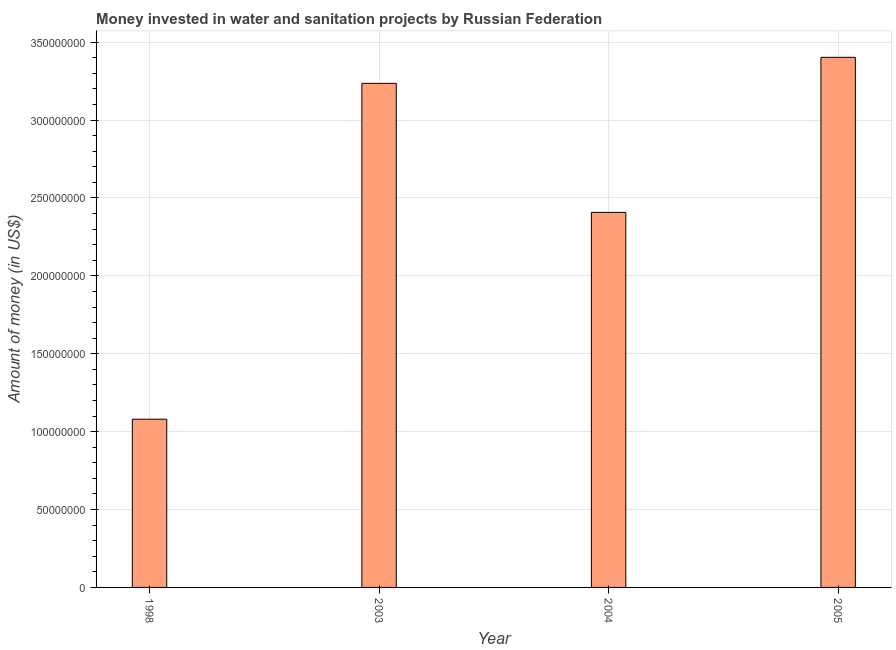What is the title of the graph?
Offer a very short reply. Money invested in water and sanitation projects by Russian Federation. What is the label or title of the X-axis?
Provide a succinct answer. Year. What is the label or title of the Y-axis?
Your response must be concise. Amount of money (in US$). What is the investment in 2003?
Offer a very short reply. 3.24e+08. Across all years, what is the maximum investment?
Give a very brief answer. 3.40e+08. Across all years, what is the minimum investment?
Your answer should be compact. 1.08e+08. What is the sum of the investment?
Ensure brevity in your answer.  1.01e+09. What is the difference between the investment in 2004 and 2005?
Your answer should be compact. -9.95e+07. What is the average investment per year?
Provide a short and direct response. 2.53e+08. What is the median investment?
Make the answer very short. 2.82e+08. Do a majority of the years between 2004 and 2005 (inclusive) have investment greater than 270000000 US$?
Keep it short and to the point. No. What is the ratio of the investment in 2004 to that in 2005?
Ensure brevity in your answer.  0.71. Is the difference between the investment in 2003 and 2004 greater than the difference between any two years?
Provide a short and direct response. No. What is the difference between the highest and the second highest investment?
Keep it short and to the point. 1.67e+07. What is the difference between the highest and the lowest investment?
Keep it short and to the point. 2.32e+08. In how many years, is the investment greater than the average investment taken over all years?
Provide a short and direct response. 2. Are the values on the major ticks of Y-axis written in scientific E-notation?
Your response must be concise. No. What is the Amount of money (in US$) of 1998?
Give a very brief answer. 1.08e+08. What is the Amount of money (in US$) of 2003?
Keep it short and to the point. 3.24e+08. What is the Amount of money (in US$) of 2004?
Provide a succinct answer. 2.41e+08. What is the Amount of money (in US$) of 2005?
Make the answer very short. 3.40e+08. What is the difference between the Amount of money (in US$) in 1998 and 2003?
Keep it short and to the point. -2.16e+08. What is the difference between the Amount of money (in US$) in 1998 and 2004?
Offer a terse response. -1.33e+08. What is the difference between the Amount of money (in US$) in 1998 and 2005?
Provide a succinct answer. -2.32e+08. What is the difference between the Amount of money (in US$) in 2003 and 2004?
Your answer should be compact. 8.28e+07. What is the difference between the Amount of money (in US$) in 2003 and 2005?
Your response must be concise. -1.67e+07. What is the difference between the Amount of money (in US$) in 2004 and 2005?
Offer a very short reply. -9.95e+07. What is the ratio of the Amount of money (in US$) in 1998 to that in 2003?
Your response must be concise. 0.33. What is the ratio of the Amount of money (in US$) in 1998 to that in 2004?
Make the answer very short. 0.45. What is the ratio of the Amount of money (in US$) in 1998 to that in 2005?
Your answer should be very brief. 0.32. What is the ratio of the Amount of money (in US$) in 2003 to that in 2004?
Offer a terse response. 1.34. What is the ratio of the Amount of money (in US$) in 2003 to that in 2005?
Make the answer very short. 0.95. What is the ratio of the Amount of money (in US$) in 2004 to that in 2005?
Offer a very short reply. 0.71. 